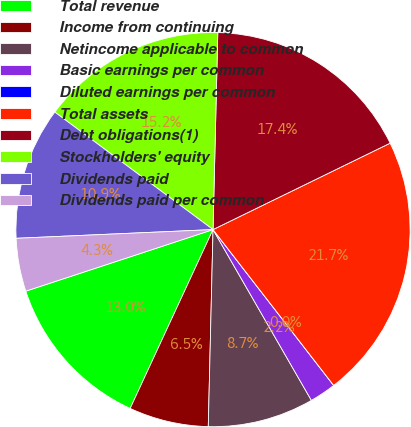Convert chart. <chart><loc_0><loc_0><loc_500><loc_500><pie_chart><fcel>Total revenue<fcel>Income from continuing<fcel>Netincome applicable to common<fcel>Basic earnings per common<fcel>Diluted earnings per common<fcel>Total assets<fcel>Debt obligations(1)<fcel>Stockholders' equity<fcel>Dividends paid<fcel>Dividends paid per common<nl><fcel>13.04%<fcel>6.52%<fcel>8.7%<fcel>2.17%<fcel>0.0%<fcel>21.74%<fcel>17.39%<fcel>15.22%<fcel>10.87%<fcel>4.35%<nl></chart> 